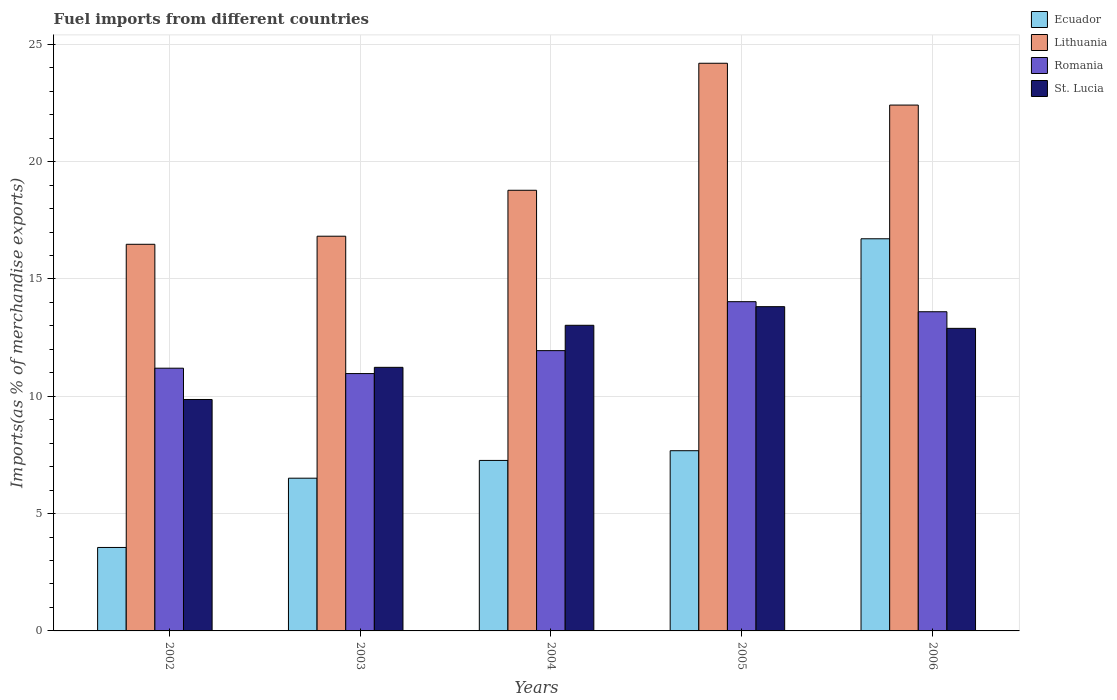How many groups of bars are there?
Make the answer very short. 5. Are the number of bars on each tick of the X-axis equal?
Give a very brief answer. Yes. What is the percentage of imports to different countries in St. Lucia in 2006?
Offer a terse response. 12.9. Across all years, what is the maximum percentage of imports to different countries in Lithuania?
Give a very brief answer. 24.2. Across all years, what is the minimum percentage of imports to different countries in Ecuador?
Your answer should be compact. 3.56. In which year was the percentage of imports to different countries in Ecuador minimum?
Make the answer very short. 2002. What is the total percentage of imports to different countries in Lithuania in the graph?
Your answer should be very brief. 98.69. What is the difference between the percentage of imports to different countries in Lithuania in 2002 and that in 2004?
Keep it short and to the point. -2.3. What is the difference between the percentage of imports to different countries in Lithuania in 2003 and the percentage of imports to different countries in Romania in 2002?
Your answer should be very brief. 5.63. What is the average percentage of imports to different countries in Lithuania per year?
Your answer should be very brief. 19.74. In the year 2003, what is the difference between the percentage of imports to different countries in St. Lucia and percentage of imports to different countries in Lithuania?
Your response must be concise. -5.59. In how many years, is the percentage of imports to different countries in Lithuania greater than 21 %?
Make the answer very short. 2. What is the ratio of the percentage of imports to different countries in Romania in 2004 to that in 2006?
Provide a succinct answer. 0.88. What is the difference between the highest and the second highest percentage of imports to different countries in Lithuania?
Provide a succinct answer. 1.78. What is the difference between the highest and the lowest percentage of imports to different countries in Ecuador?
Offer a very short reply. 13.16. Is it the case that in every year, the sum of the percentage of imports to different countries in Ecuador and percentage of imports to different countries in Lithuania is greater than the sum of percentage of imports to different countries in St. Lucia and percentage of imports to different countries in Romania?
Give a very brief answer. No. What does the 4th bar from the left in 2003 represents?
Offer a very short reply. St. Lucia. What does the 4th bar from the right in 2004 represents?
Give a very brief answer. Ecuador. Is it the case that in every year, the sum of the percentage of imports to different countries in Lithuania and percentage of imports to different countries in Ecuador is greater than the percentage of imports to different countries in St. Lucia?
Offer a very short reply. Yes. What is the difference between two consecutive major ticks on the Y-axis?
Your answer should be very brief. 5. Are the values on the major ticks of Y-axis written in scientific E-notation?
Make the answer very short. No. How many legend labels are there?
Provide a short and direct response. 4. What is the title of the graph?
Offer a terse response. Fuel imports from different countries. Does "Turkey" appear as one of the legend labels in the graph?
Provide a succinct answer. No. What is the label or title of the Y-axis?
Offer a terse response. Imports(as % of merchandise exports). What is the Imports(as % of merchandise exports) in Ecuador in 2002?
Ensure brevity in your answer.  3.56. What is the Imports(as % of merchandise exports) of Lithuania in 2002?
Make the answer very short. 16.48. What is the Imports(as % of merchandise exports) of Romania in 2002?
Your response must be concise. 11.2. What is the Imports(as % of merchandise exports) in St. Lucia in 2002?
Your answer should be very brief. 9.86. What is the Imports(as % of merchandise exports) of Ecuador in 2003?
Ensure brevity in your answer.  6.51. What is the Imports(as % of merchandise exports) of Lithuania in 2003?
Keep it short and to the point. 16.82. What is the Imports(as % of merchandise exports) of Romania in 2003?
Make the answer very short. 10.97. What is the Imports(as % of merchandise exports) in St. Lucia in 2003?
Offer a terse response. 11.23. What is the Imports(as % of merchandise exports) of Ecuador in 2004?
Give a very brief answer. 7.27. What is the Imports(as % of merchandise exports) of Lithuania in 2004?
Provide a short and direct response. 18.78. What is the Imports(as % of merchandise exports) in Romania in 2004?
Ensure brevity in your answer.  11.95. What is the Imports(as % of merchandise exports) in St. Lucia in 2004?
Give a very brief answer. 13.03. What is the Imports(as % of merchandise exports) of Ecuador in 2005?
Keep it short and to the point. 7.68. What is the Imports(as % of merchandise exports) in Lithuania in 2005?
Give a very brief answer. 24.2. What is the Imports(as % of merchandise exports) of Romania in 2005?
Your answer should be very brief. 14.03. What is the Imports(as % of merchandise exports) of St. Lucia in 2005?
Offer a very short reply. 13.82. What is the Imports(as % of merchandise exports) in Ecuador in 2006?
Your answer should be very brief. 16.71. What is the Imports(as % of merchandise exports) of Lithuania in 2006?
Provide a short and direct response. 22.41. What is the Imports(as % of merchandise exports) of Romania in 2006?
Provide a succinct answer. 13.6. What is the Imports(as % of merchandise exports) of St. Lucia in 2006?
Your response must be concise. 12.9. Across all years, what is the maximum Imports(as % of merchandise exports) of Ecuador?
Give a very brief answer. 16.71. Across all years, what is the maximum Imports(as % of merchandise exports) in Lithuania?
Provide a succinct answer. 24.2. Across all years, what is the maximum Imports(as % of merchandise exports) in Romania?
Ensure brevity in your answer.  14.03. Across all years, what is the maximum Imports(as % of merchandise exports) of St. Lucia?
Provide a short and direct response. 13.82. Across all years, what is the minimum Imports(as % of merchandise exports) of Ecuador?
Make the answer very short. 3.56. Across all years, what is the minimum Imports(as % of merchandise exports) in Lithuania?
Make the answer very short. 16.48. Across all years, what is the minimum Imports(as % of merchandise exports) in Romania?
Provide a succinct answer. 10.97. Across all years, what is the minimum Imports(as % of merchandise exports) in St. Lucia?
Your response must be concise. 9.86. What is the total Imports(as % of merchandise exports) in Ecuador in the graph?
Make the answer very short. 41.73. What is the total Imports(as % of merchandise exports) of Lithuania in the graph?
Your answer should be compact. 98.69. What is the total Imports(as % of merchandise exports) of Romania in the graph?
Give a very brief answer. 61.75. What is the total Imports(as % of merchandise exports) in St. Lucia in the graph?
Offer a very short reply. 60.84. What is the difference between the Imports(as % of merchandise exports) of Ecuador in 2002 and that in 2003?
Offer a very short reply. -2.95. What is the difference between the Imports(as % of merchandise exports) in Lithuania in 2002 and that in 2003?
Offer a terse response. -0.34. What is the difference between the Imports(as % of merchandise exports) in Romania in 2002 and that in 2003?
Your response must be concise. 0.23. What is the difference between the Imports(as % of merchandise exports) in St. Lucia in 2002 and that in 2003?
Make the answer very short. -1.37. What is the difference between the Imports(as % of merchandise exports) in Ecuador in 2002 and that in 2004?
Give a very brief answer. -3.71. What is the difference between the Imports(as % of merchandise exports) in Lithuania in 2002 and that in 2004?
Provide a succinct answer. -2.3. What is the difference between the Imports(as % of merchandise exports) of Romania in 2002 and that in 2004?
Offer a terse response. -0.75. What is the difference between the Imports(as % of merchandise exports) in St. Lucia in 2002 and that in 2004?
Make the answer very short. -3.16. What is the difference between the Imports(as % of merchandise exports) of Ecuador in 2002 and that in 2005?
Provide a short and direct response. -4.12. What is the difference between the Imports(as % of merchandise exports) in Lithuania in 2002 and that in 2005?
Give a very brief answer. -7.72. What is the difference between the Imports(as % of merchandise exports) of Romania in 2002 and that in 2005?
Offer a terse response. -2.83. What is the difference between the Imports(as % of merchandise exports) in St. Lucia in 2002 and that in 2005?
Keep it short and to the point. -3.96. What is the difference between the Imports(as % of merchandise exports) of Ecuador in 2002 and that in 2006?
Keep it short and to the point. -13.16. What is the difference between the Imports(as % of merchandise exports) in Lithuania in 2002 and that in 2006?
Your answer should be compact. -5.93. What is the difference between the Imports(as % of merchandise exports) in Romania in 2002 and that in 2006?
Provide a short and direct response. -2.41. What is the difference between the Imports(as % of merchandise exports) in St. Lucia in 2002 and that in 2006?
Provide a short and direct response. -3.03. What is the difference between the Imports(as % of merchandise exports) in Ecuador in 2003 and that in 2004?
Give a very brief answer. -0.76. What is the difference between the Imports(as % of merchandise exports) of Lithuania in 2003 and that in 2004?
Your response must be concise. -1.96. What is the difference between the Imports(as % of merchandise exports) in Romania in 2003 and that in 2004?
Offer a very short reply. -0.98. What is the difference between the Imports(as % of merchandise exports) of St. Lucia in 2003 and that in 2004?
Your answer should be compact. -1.79. What is the difference between the Imports(as % of merchandise exports) of Ecuador in 2003 and that in 2005?
Your answer should be compact. -1.17. What is the difference between the Imports(as % of merchandise exports) of Lithuania in 2003 and that in 2005?
Ensure brevity in your answer.  -7.37. What is the difference between the Imports(as % of merchandise exports) of Romania in 2003 and that in 2005?
Make the answer very short. -3.06. What is the difference between the Imports(as % of merchandise exports) in St. Lucia in 2003 and that in 2005?
Provide a succinct answer. -2.59. What is the difference between the Imports(as % of merchandise exports) in Ecuador in 2003 and that in 2006?
Make the answer very short. -10.2. What is the difference between the Imports(as % of merchandise exports) of Lithuania in 2003 and that in 2006?
Your answer should be compact. -5.59. What is the difference between the Imports(as % of merchandise exports) of Romania in 2003 and that in 2006?
Your answer should be very brief. -2.64. What is the difference between the Imports(as % of merchandise exports) in St. Lucia in 2003 and that in 2006?
Keep it short and to the point. -1.66. What is the difference between the Imports(as % of merchandise exports) in Ecuador in 2004 and that in 2005?
Your response must be concise. -0.41. What is the difference between the Imports(as % of merchandise exports) in Lithuania in 2004 and that in 2005?
Ensure brevity in your answer.  -5.41. What is the difference between the Imports(as % of merchandise exports) of Romania in 2004 and that in 2005?
Give a very brief answer. -2.09. What is the difference between the Imports(as % of merchandise exports) in St. Lucia in 2004 and that in 2005?
Provide a succinct answer. -0.79. What is the difference between the Imports(as % of merchandise exports) of Ecuador in 2004 and that in 2006?
Ensure brevity in your answer.  -9.45. What is the difference between the Imports(as % of merchandise exports) in Lithuania in 2004 and that in 2006?
Your answer should be compact. -3.63. What is the difference between the Imports(as % of merchandise exports) of Romania in 2004 and that in 2006?
Provide a short and direct response. -1.66. What is the difference between the Imports(as % of merchandise exports) in St. Lucia in 2004 and that in 2006?
Your answer should be very brief. 0.13. What is the difference between the Imports(as % of merchandise exports) in Ecuador in 2005 and that in 2006?
Give a very brief answer. -9.03. What is the difference between the Imports(as % of merchandise exports) in Lithuania in 2005 and that in 2006?
Keep it short and to the point. 1.78. What is the difference between the Imports(as % of merchandise exports) in Romania in 2005 and that in 2006?
Your answer should be very brief. 0.43. What is the difference between the Imports(as % of merchandise exports) of St. Lucia in 2005 and that in 2006?
Your answer should be compact. 0.92. What is the difference between the Imports(as % of merchandise exports) of Ecuador in 2002 and the Imports(as % of merchandise exports) of Lithuania in 2003?
Offer a very short reply. -13.27. What is the difference between the Imports(as % of merchandise exports) in Ecuador in 2002 and the Imports(as % of merchandise exports) in Romania in 2003?
Give a very brief answer. -7.41. What is the difference between the Imports(as % of merchandise exports) of Ecuador in 2002 and the Imports(as % of merchandise exports) of St. Lucia in 2003?
Make the answer very short. -7.68. What is the difference between the Imports(as % of merchandise exports) of Lithuania in 2002 and the Imports(as % of merchandise exports) of Romania in 2003?
Offer a terse response. 5.51. What is the difference between the Imports(as % of merchandise exports) of Lithuania in 2002 and the Imports(as % of merchandise exports) of St. Lucia in 2003?
Offer a very short reply. 5.24. What is the difference between the Imports(as % of merchandise exports) of Romania in 2002 and the Imports(as % of merchandise exports) of St. Lucia in 2003?
Provide a short and direct response. -0.04. What is the difference between the Imports(as % of merchandise exports) in Ecuador in 2002 and the Imports(as % of merchandise exports) in Lithuania in 2004?
Keep it short and to the point. -15.22. What is the difference between the Imports(as % of merchandise exports) in Ecuador in 2002 and the Imports(as % of merchandise exports) in Romania in 2004?
Ensure brevity in your answer.  -8.39. What is the difference between the Imports(as % of merchandise exports) of Ecuador in 2002 and the Imports(as % of merchandise exports) of St. Lucia in 2004?
Offer a terse response. -9.47. What is the difference between the Imports(as % of merchandise exports) in Lithuania in 2002 and the Imports(as % of merchandise exports) in Romania in 2004?
Offer a very short reply. 4.53. What is the difference between the Imports(as % of merchandise exports) of Lithuania in 2002 and the Imports(as % of merchandise exports) of St. Lucia in 2004?
Offer a very short reply. 3.45. What is the difference between the Imports(as % of merchandise exports) in Romania in 2002 and the Imports(as % of merchandise exports) in St. Lucia in 2004?
Keep it short and to the point. -1.83. What is the difference between the Imports(as % of merchandise exports) in Ecuador in 2002 and the Imports(as % of merchandise exports) in Lithuania in 2005?
Your response must be concise. -20.64. What is the difference between the Imports(as % of merchandise exports) of Ecuador in 2002 and the Imports(as % of merchandise exports) of Romania in 2005?
Your answer should be very brief. -10.48. What is the difference between the Imports(as % of merchandise exports) in Ecuador in 2002 and the Imports(as % of merchandise exports) in St. Lucia in 2005?
Give a very brief answer. -10.26. What is the difference between the Imports(as % of merchandise exports) of Lithuania in 2002 and the Imports(as % of merchandise exports) of Romania in 2005?
Offer a terse response. 2.45. What is the difference between the Imports(as % of merchandise exports) of Lithuania in 2002 and the Imports(as % of merchandise exports) of St. Lucia in 2005?
Your answer should be compact. 2.66. What is the difference between the Imports(as % of merchandise exports) of Romania in 2002 and the Imports(as % of merchandise exports) of St. Lucia in 2005?
Your answer should be compact. -2.62. What is the difference between the Imports(as % of merchandise exports) of Ecuador in 2002 and the Imports(as % of merchandise exports) of Lithuania in 2006?
Provide a succinct answer. -18.86. What is the difference between the Imports(as % of merchandise exports) in Ecuador in 2002 and the Imports(as % of merchandise exports) in Romania in 2006?
Provide a short and direct response. -10.05. What is the difference between the Imports(as % of merchandise exports) in Ecuador in 2002 and the Imports(as % of merchandise exports) in St. Lucia in 2006?
Your response must be concise. -9.34. What is the difference between the Imports(as % of merchandise exports) in Lithuania in 2002 and the Imports(as % of merchandise exports) in Romania in 2006?
Keep it short and to the point. 2.87. What is the difference between the Imports(as % of merchandise exports) of Lithuania in 2002 and the Imports(as % of merchandise exports) of St. Lucia in 2006?
Make the answer very short. 3.58. What is the difference between the Imports(as % of merchandise exports) of Romania in 2002 and the Imports(as % of merchandise exports) of St. Lucia in 2006?
Provide a succinct answer. -1.7. What is the difference between the Imports(as % of merchandise exports) in Ecuador in 2003 and the Imports(as % of merchandise exports) in Lithuania in 2004?
Offer a terse response. -12.27. What is the difference between the Imports(as % of merchandise exports) of Ecuador in 2003 and the Imports(as % of merchandise exports) of Romania in 2004?
Ensure brevity in your answer.  -5.44. What is the difference between the Imports(as % of merchandise exports) in Ecuador in 2003 and the Imports(as % of merchandise exports) in St. Lucia in 2004?
Give a very brief answer. -6.52. What is the difference between the Imports(as % of merchandise exports) of Lithuania in 2003 and the Imports(as % of merchandise exports) of Romania in 2004?
Make the answer very short. 4.88. What is the difference between the Imports(as % of merchandise exports) of Lithuania in 2003 and the Imports(as % of merchandise exports) of St. Lucia in 2004?
Give a very brief answer. 3.8. What is the difference between the Imports(as % of merchandise exports) of Romania in 2003 and the Imports(as % of merchandise exports) of St. Lucia in 2004?
Make the answer very short. -2.06. What is the difference between the Imports(as % of merchandise exports) in Ecuador in 2003 and the Imports(as % of merchandise exports) in Lithuania in 2005?
Offer a terse response. -17.69. What is the difference between the Imports(as % of merchandise exports) in Ecuador in 2003 and the Imports(as % of merchandise exports) in Romania in 2005?
Give a very brief answer. -7.52. What is the difference between the Imports(as % of merchandise exports) of Ecuador in 2003 and the Imports(as % of merchandise exports) of St. Lucia in 2005?
Provide a short and direct response. -7.31. What is the difference between the Imports(as % of merchandise exports) of Lithuania in 2003 and the Imports(as % of merchandise exports) of Romania in 2005?
Make the answer very short. 2.79. What is the difference between the Imports(as % of merchandise exports) of Lithuania in 2003 and the Imports(as % of merchandise exports) of St. Lucia in 2005?
Offer a very short reply. 3. What is the difference between the Imports(as % of merchandise exports) of Romania in 2003 and the Imports(as % of merchandise exports) of St. Lucia in 2005?
Provide a succinct answer. -2.85. What is the difference between the Imports(as % of merchandise exports) of Ecuador in 2003 and the Imports(as % of merchandise exports) of Lithuania in 2006?
Ensure brevity in your answer.  -15.9. What is the difference between the Imports(as % of merchandise exports) of Ecuador in 2003 and the Imports(as % of merchandise exports) of Romania in 2006?
Your response must be concise. -7.09. What is the difference between the Imports(as % of merchandise exports) of Ecuador in 2003 and the Imports(as % of merchandise exports) of St. Lucia in 2006?
Give a very brief answer. -6.39. What is the difference between the Imports(as % of merchandise exports) in Lithuania in 2003 and the Imports(as % of merchandise exports) in Romania in 2006?
Ensure brevity in your answer.  3.22. What is the difference between the Imports(as % of merchandise exports) in Lithuania in 2003 and the Imports(as % of merchandise exports) in St. Lucia in 2006?
Your response must be concise. 3.93. What is the difference between the Imports(as % of merchandise exports) of Romania in 2003 and the Imports(as % of merchandise exports) of St. Lucia in 2006?
Ensure brevity in your answer.  -1.93. What is the difference between the Imports(as % of merchandise exports) of Ecuador in 2004 and the Imports(as % of merchandise exports) of Lithuania in 2005?
Offer a terse response. -16.93. What is the difference between the Imports(as % of merchandise exports) of Ecuador in 2004 and the Imports(as % of merchandise exports) of Romania in 2005?
Make the answer very short. -6.77. What is the difference between the Imports(as % of merchandise exports) of Ecuador in 2004 and the Imports(as % of merchandise exports) of St. Lucia in 2005?
Provide a short and direct response. -6.55. What is the difference between the Imports(as % of merchandise exports) in Lithuania in 2004 and the Imports(as % of merchandise exports) in Romania in 2005?
Provide a short and direct response. 4.75. What is the difference between the Imports(as % of merchandise exports) of Lithuania in 2004 and the Imports(as % of merchandise exports) of St. Lucia in 2005?
Ensure brevity in your answer.  4.96. What is the difference between the Imports(as % of merchandise exports) in Romania in 2004 and the Imports(as % of merchandise exports) in St. Lucia in 2005?
Provide a short and direct response. -1.87. What is the difference between the Imports(as % of merchandise exports) of Ecuador in 2004 and the Imports(as % of merchandise exports) of Lithuania in 2006?
Your answer should be very brief. -15.15. What is the difference between the Imports(as % of merchandise exports) in Ecuador in 2004 and the Imports(as % of merchandise exports) in Romania in 2006?
Offer a terse response. -6.34. What is the difference between the Imports(as % of merchandise exports) in Ecuador in 2004 and the Imports(as % of merchandise exports) in St. Lucia in 2006?
Provide a short and direct response. -5.63. What is the difference between the Imports(as % of merchandise exports) of Lithuania in 2004 and the Imports(as % of merchandise exports) of Romania in 2006?
Ensure brevity in your answer.  5.18. What is the difference between the Imports(as % of merchandise exports) of Lithuania in 2004 and the Imports(as % of merchandise exports) of St. Lucia in 2006?
Give a very brief answer. 5.89. What is the difference between the Imports(as % of merchandise exports) of Romania in 2004 and the Imports(as % of merchandise exports) of St. Lucia in 2006?
Provide a succinct answer. -0.95. What is the difference between the Imports(as % of merchandise exports) of Ecuador in 2005 and the Imports(as % of merchandise exports) of Lithuania in 2006?
Your response must be concise. -14.73. What is the difference between the Imports(as % of merchandise exports) in Ecuador in 2005 and the Imports(as % of merchandise exports) in Romania in 2006?
Your response must be concise. -5.92. What is the difference between the Imports(as % of merchandise exports) of Ecuador in 2005 and the Imports(as % of merchandise exports) of St. Lucia in 2006?
Provide a succinct answer. -5.21. What is the difference between the Imports(as % of merchandise exports) of Lithuania in 2005 and the Imports(as % of merchandise exports) of Romania in 2006?
Provide a short and direct response. 10.59. What is the difference between the Imports(as % of merchandise exports) in Lithuania in 2005 and the Imports(as % of merchandise exports) in St. Lucia in 2006?
Your answer should be very brief. 11.3. What is the difference between the Imports(as % of merchandise exports) in Romania in 2005 and the Imports(as % of merchandise exports) in St. Lucia in 2006?
Your answer should be very brief. 1.14. What is the average Imports(as % of merchandise exports) of Ecuador per year?
Ensure brevity in your answer.  8.35. What is the average Imports(as % of merchandise exports) in Lithuania per year?
Your answer should be very brief. 19.74. What is the average Imports(as % of merchandise exports) of Romania per year?
Keep it short and to the point. 12.35. What is the average Imports(as % of merchandise exports) of St. Lucia per year?
Make the answer very short. 12.17. In the year 2002, what is the difference between the Imports(as % of merchandise exports) of Ecuador and Imports(as % of merchandise exports) of Lithuania?
Your response must be concise. -12.92. In the year 2002, what is the difference between the Imports(as % of merchandise exports) in Ecuador and Imports(as % of merchandise exports) in Romania?
Make the answer very short. -7.64. In the year 2002, what is the difference between the Imports(as % of merchandise exports) of Ecuador and Imports(as % of merchandise exports) of St. Lucia?
Your response must be concise. -6.31. In the year 2002, what is the difference between the Imports(as % of merchandise exports) in Lithuania and Imports(as % of merchandise exports) in Romania?
Provide a short and direct response. 5.28. In the year 2002, what is the difference between the Imports(as % of merchandise exports) in Lithuania and Imports(as % of merchandise exports) in St. Lucia?
Provide a short and direct response. 6.61. In the year 2002, what is the difference between the Imports(as % of merchandise exports) of Romania and Imports(as % of merchandise exports) of St. Lucia?
Ensure brevity in your answer.  1.33. In the year 2003, what is the difference between the Imports(as % of merchandise exports) of Ecuador and Imports(as % of merchandise exports) of Lithuania?
Your answer should be compact. -10.31. In the year 2003, what is the difference between the Imports(as % of merchandise exports) of Ecuador and Imports(as % of merchandise exports) of Romania?
Offer a terse response. -4.46. In the year 2003, what is the difference between the Imports(as % of merchandise exports) in Ecuador and Imports(as % of merchandise exports) in St. Lucia?
Give a very brief answer. -4.72. In the year 2003, what is the difference between the Imports(as % of merchandise exports) in Lithuania and Imports(as % of merchandise exports) in Romania?
Offer a very short reply. 5.85. In the year 2003, what is the difference between the Imports(as % of merchandise exports) in Lithuania and Imports(as % of merchandise exports) in St. Lucia?
Give a very brief answer. 5.59. In the year 2003, what is the difference between the Imports(as % of merchandise exports) of Romania and Imports(as % of merchandise exports) of St. Lucia?
Your answer should be compact. -0.27. In the year 2004, what is the difference between the Imports(as % of merchandise exports) of Ecuador and Imports(as % of merchandise exports) of Lithuania?
Provide a succinct answer. -11.51. In the year 2004, what is the difference between the Imports(as % of merchandise exports) of Ecuador and Imports(as % of merchandise exports) of Romania?
Your answer should be compact. -4.68. In the year 2004, what is the difference between the Imports(as % of merchandise exports) in Ecuador and Imports(as % of merchandise exports) in St. Lucia?
Make the answer very short. -5.76. In the year 2004, what is the difference between the Imports(as % of merchandise exports) in Lithuania and Imports(as % of merchandise exports) in Romania?
Your response must be concise. 6.84. In the year 2004, what is the difference between the Imports(as % of merchandise exports) in Lithuania and Imports(as % of merchandise exports) in St. Lucia?
Your response must be concise. 5.75. In the year 2004, what is the difference between the Imports(as % of merchandise exports) of Romania and Imports(as % of merchandise exports) of St. Lucia?
Offer a terse response. -1.08. In the year 2005, what is the difference between the Imports(as % of merchandise exports) in Ecuador and Imports(as % of merchandise exports) in Lithuania?
Provide a short and direct response. -16.51. In the year 2005, what is the difference between the Imports(as % of merchandise exports) of Ecuador and Imports(as % of merchandise exports) of Romania?
Your answer should be very brief. -6.35. In the year 2005, what is the difference between the Imports(as % of merchandise exports) in Ecuador and Imports(as % of merchandise exports) in St. Lucia?
Offer a terse response. -6.14. In the year 2005, what is the difference between the Imports(as % of merchandise exports) in Lithuania and Imports(as % of merchandise exports) in Romania?
Your answer should be very brief. 10.16. In the year 2005, what is the difference between the Imports(as % of merchandise exports) of Lithuania and Imports(as % of merchandise exports) of St. Lucia?
Your answer should be compact. 10.37. In the year 2005, what is the difference between the Imports(as % of merchandise exports) of Romania and Imports(as % of merchandise exports) of St. Lucia?
Provide a succinct answer. 0.21. In the year 2006, what is the difference between the Imports(as % of merchandise exports) of Ecuador and Imports(as % of merchandise exports) of Lithuania?
Offer a very short reply. -5.7. In the year 2006, what is the difference between the Imports(as % of merchandise exports) of Ecuador and Imports(as % of merchandise exports) of Romania?
Your response must be concise. 3.11. In the year 2006, what is the difference between the Imports(as % of merchandise exports) in Ecuador and Imports(as % of merchandise exports) in St. Lucia?
Give a very brief answer. 3.82. In the year 2006, what is the difference between the Imports(as % of merchandise exports) of Lithuania and Imports(as % of merchandise exports) of Romania?
Give a very brief answer. 8.81. In the year 2006, what is the difference between the Imports(as % of merchandise exports) in Lithuania and Imports(as % of merchandise exports) in St. Lucia?
Your answer should be very brief. 9.52. In the year 2006, what is the difference between the Imports(as % of merchandise exports) of Romania and Imports(as % of merchandise exports) of St. Lucia?
Give a very brief answer. 0.71. What is the ratio of the Imports(as % of merchandise exports) in Ecuador in 2002 to that in 2003?
Make the answer very short. 0.55. What is the ratio of the Imports(as % of merchandise exports) in Lithuania in 2002 to that in 2003?
Offer a very short reply. 0.98. What is the ratio of the Imports(as % of merchandise exports) of Romania in 2002 to that in 2003?
Give a very brief answer. 1.02. What is the ratio of the Imports(as % of merchandise exports) of St. Lucia in 2002 to that in 2003?
Offer a very short reply. 0.88. What is the ratio of the Imports(as % of merchandise exports) in Ecuador in 2002 to that in 2004?
Your response must be concise. 0.49. What is the ratio of the Imports(as % of merchandise exports) in Lithuania in 2002 to that in 2004?
Keep it short and to the point. 0.88. What is the ratio of the Imports(as % of merchandise exports) of Romania in 2002 to that in 2004?
Give a very brief answer. 0.94. What is the ratio of the Imports(as % of merchandise exports) in St. Lucia in 2002 to that in 2004?
Provide a short and direct response. 0.76. What is the ratio of the Imports(as % of merchandise exports) in Ecuador in 2002 to that in 2005?
Make the answer very short. 0.46. What is the ratio of the Imports(as % of merchandise exports) in Lithuania in 2002 to that in 2005?
Provide a succinct answer. 0.68. What is the ratio of the Imports(as % of merchandise exports) in Romania in 2002 to that in 2005?
Provide a succinct answer. 0.8. What is the ratio of the Imports(as % of merchandise exports) of St. Lucia in 2002 to that in 2005?
Ensure brevity in your answer.  0.71. What is the ratio of the Imports(as % of merchandise exports) in Ecuador in 2002 to that in 2006?
Keep it short and to the point. 0.21. What is the ratio of the Imports(as % of merchandise exports) of Lithuania in 2002 to that in 2006?
Offer a terse response. 0.74. What is the ratio of the Imports(as % of merchandise exports) in Romania in 2002 to that in 2006?
Ensure brevity in your answer.  0.82. What is the ratio of the Imports(as % of merchandise exports) of St. Lucia in 2002 to that in 2006?
Provide a succinct answer. 0.76. What is the ratio of the Imports(as % of merchandise exports) of Ecuador in 2003 to that in 2004?
Your answer should be compact. 0.9. What is the ratio of the Imports(as % of merchandise exports) of Lithuania in 2003 to that in 2004?
Offer a very short reply. 0.9. What is the ratio of the Imports(as % of merchandise exports) in Romania in 2003 to that in 2004?
Your answer should be very brief. 0.92. What is the ratio of the Imports(as % of merchandise exports) in St. Lucia in 2003 to that in 2004?
Your answer should be compact. 0.86. What is the ratio of the Imports(as % of merchandise exports) of Ecuador in 2003 to that in 2005?
Ensure brevity in your answer.  0.85. What is the ratio of the Imports(as % of merchandise exports) in Lithuania in 2003 to that in 2005?
Provide a succinct answer. 0.7. What is the ratio of the Imports(as % of merchandise exports) in Romania in 2003 to that in 2005?
Offer a terse response. 0.78. What is the ratio of the Imports(as % of merchandise exports) in St. Lucia in 2003 to that in 2005?
Ensure brevity in your answer.  0.81. What is the ratio of the Imports(as % of merchandise exports) in Ecuador in 2003 to that in 2006?
Provide a short and direct response. 0.39. What is the ratio of the Imports(as % of merchandise exports) of Lithuania in 2003 to that in 2006?
Offer a terse response. 0.75. What is the ratio of the Imports(as % of merchandise exports) of Romania in 2003 to that in 2006?
Your response must be concise. 0.81. What is the ratio of the Imports(as % of merchandise exports) of St. Lucia in 2003 to that in 2006?
Keep it short and to the point. 0.87. What is the ratio of the Imports(as % of merchandise exports) in Ecuador in 2004 to that in 2005?
Your answer should be compact. 0.95. What is the ratio of the Imports(as % of merchandise exports) of Lithuania in 2004 to that in 2005?
Your answer should be compact. 0.78. What is the ratio of the Imports(as % of merchandise exports) in Romania in 2004 to that in 2005?
Provide a succinct answer. 0.85. What is the ratio of the Imports(as % of merchandise exports) of St. Lucia in 2004 to that in 2005?
Provide a succinct answer. 0.94. What is the ratio of the Imports(as % of merchandise exports) in Ecuador in 2004 to that in 2006?
Your response must be concise. 0.43. What is the ratio of the Imports(as % of merchandise exports) of Lithuania in 2004 to that in 2006?
Your answer should be very brief. 0.84. What is the ratio of the Imports(as % of merchandise exports) of Romania in 2004 to that in 2006?
Make the answer very short. 0.88. What is the ratio of the Imports(as % of merchandise exports) of Ecuador in 2005 to that in 2006?
Make the answer very short. 0.46. What is the ratio of the Imports(as % of merchandise exports) of Lithuania in 2005 to that in 2006?
Your answer should be very brief. 1.08. What is the ratio of the Imports(as % of merchandise exports) of Romania in 2005 to that in 2006?
Provide a short and direct response. 1.03. What is the ratio of the Imports(as % of merchandise exports) in St. Lucia in 2005 to that in 2006?
Ensure brevity in your answer.  1.07. What is the difference between the highest and the second highest Imports(as % of merchandise exports) in Ecuador?
Ensure brevity in your answer.  9.03. What is the difference between the highest and the second highest Imports(as % of merchandise exports) of Lithuania?
Provide a succinct answer. 1.78. What is the difference between the highest and the second highest Imports(as % of merchandise exports) in Romania?
Your response must be concise. 0.43. What is the difference between the highest and the second highest Imports(as % of merchandise exports) in St. Lucia?
Provide a short and direct response. 0.79. What is the difference between the highest and the lowest Imports(as % of merchandise exports) of Ecuador?
Provide a succinct answer. 13.16. What is the difference between the highest and the lowest Imports(as % of merchandise exports) of Lithuania?
Make the answer very short. 7.72. What is the difference between the highest and the lowest Imports(as % of merchandise exports) in Romania?
Provide a short and direct response. 3.06. What is the difference between the highest and the lowest Imports(as % of merchandise exports) of St. Lucia?
Provide a succinct answer. 3.96. 